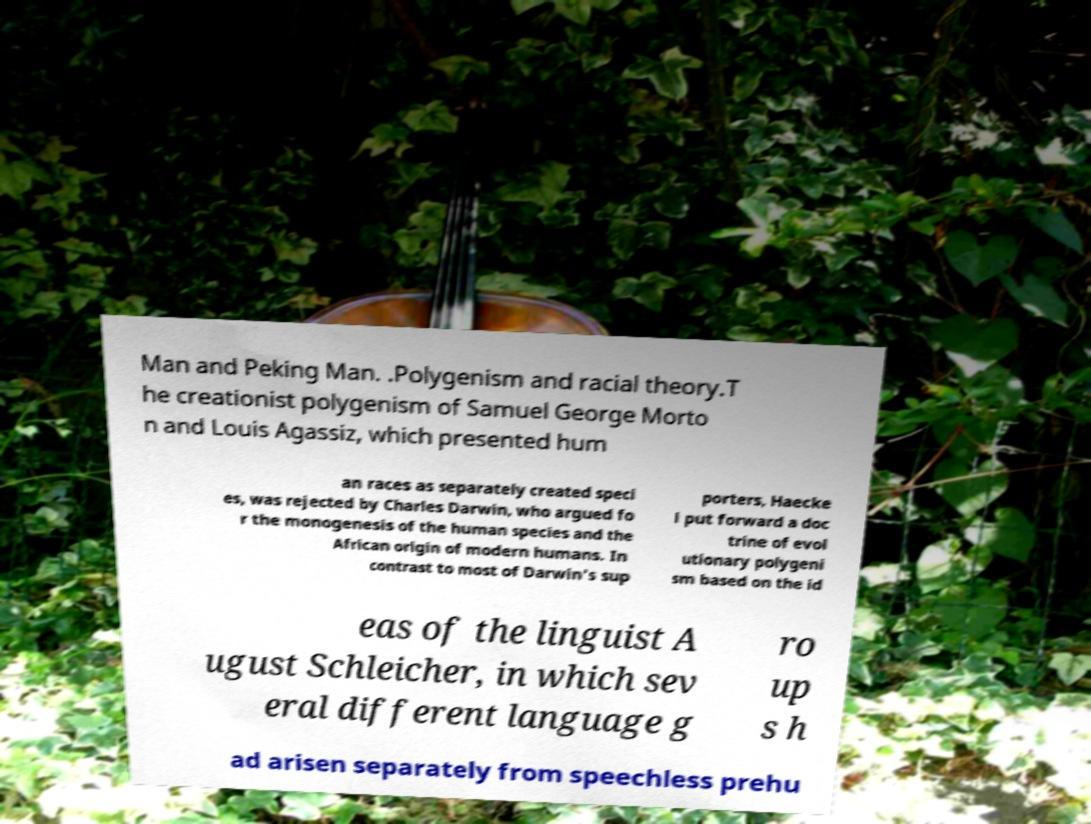Could you extract and type out the text from this image? Man and Peking Man. .Polygenism and racial theory.T he creationist polygenism of Samuel George Morto n and Louis Agassiz, which presented hum an races as separately created speci es, was rejected by Charles Darwin, who argued fo r the monogenesis of the human species and the African origin of modern humans. In contrast to most of Darwin's sup porters, Haecke l put forward a doc trine of evol utionary polygeni sm based on the id eas of the linguist A ugust Schleicher, in which sev eral different language g ro up s h ad arisen separately from speechless prehu 